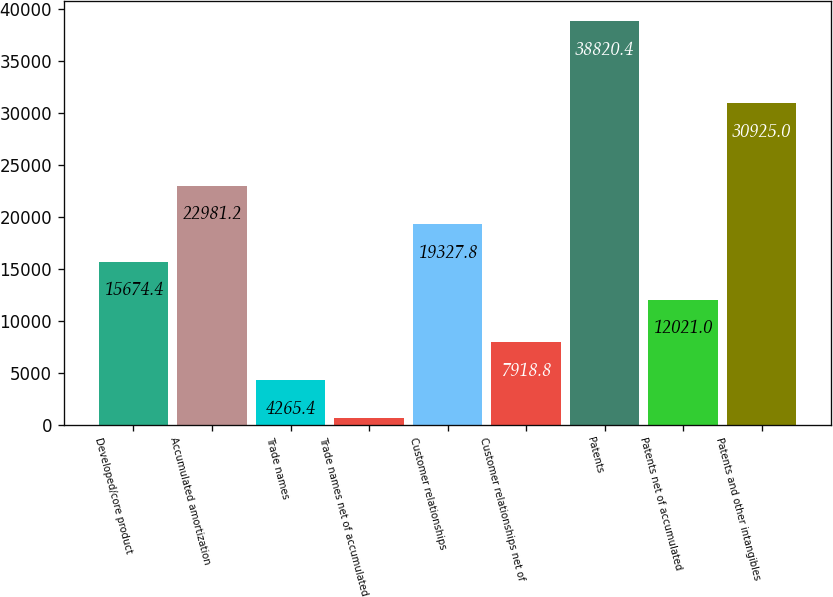Convert chart to OTSL. <chart><loc_0><loc_0><loc_500><loc_500><bar_chart><fcel>Developed/core product<fcel>Accumulated amortization<fcel>Trade names<fcel>Trade names net of accumulated<fcel>Customer relationships<fcel>Customer relationships net of<fcel>Patents<fcel>Patents net of accumulated<fcel>Patents and other intangibles<nl><fcel>15674.4<fcel>22981.2<fcel>4265.4<fcel>612<fcel>19327.8<fcel>7918.8<fcel>38820.4<fcel>12021<fcel>30925<nl></chart> 